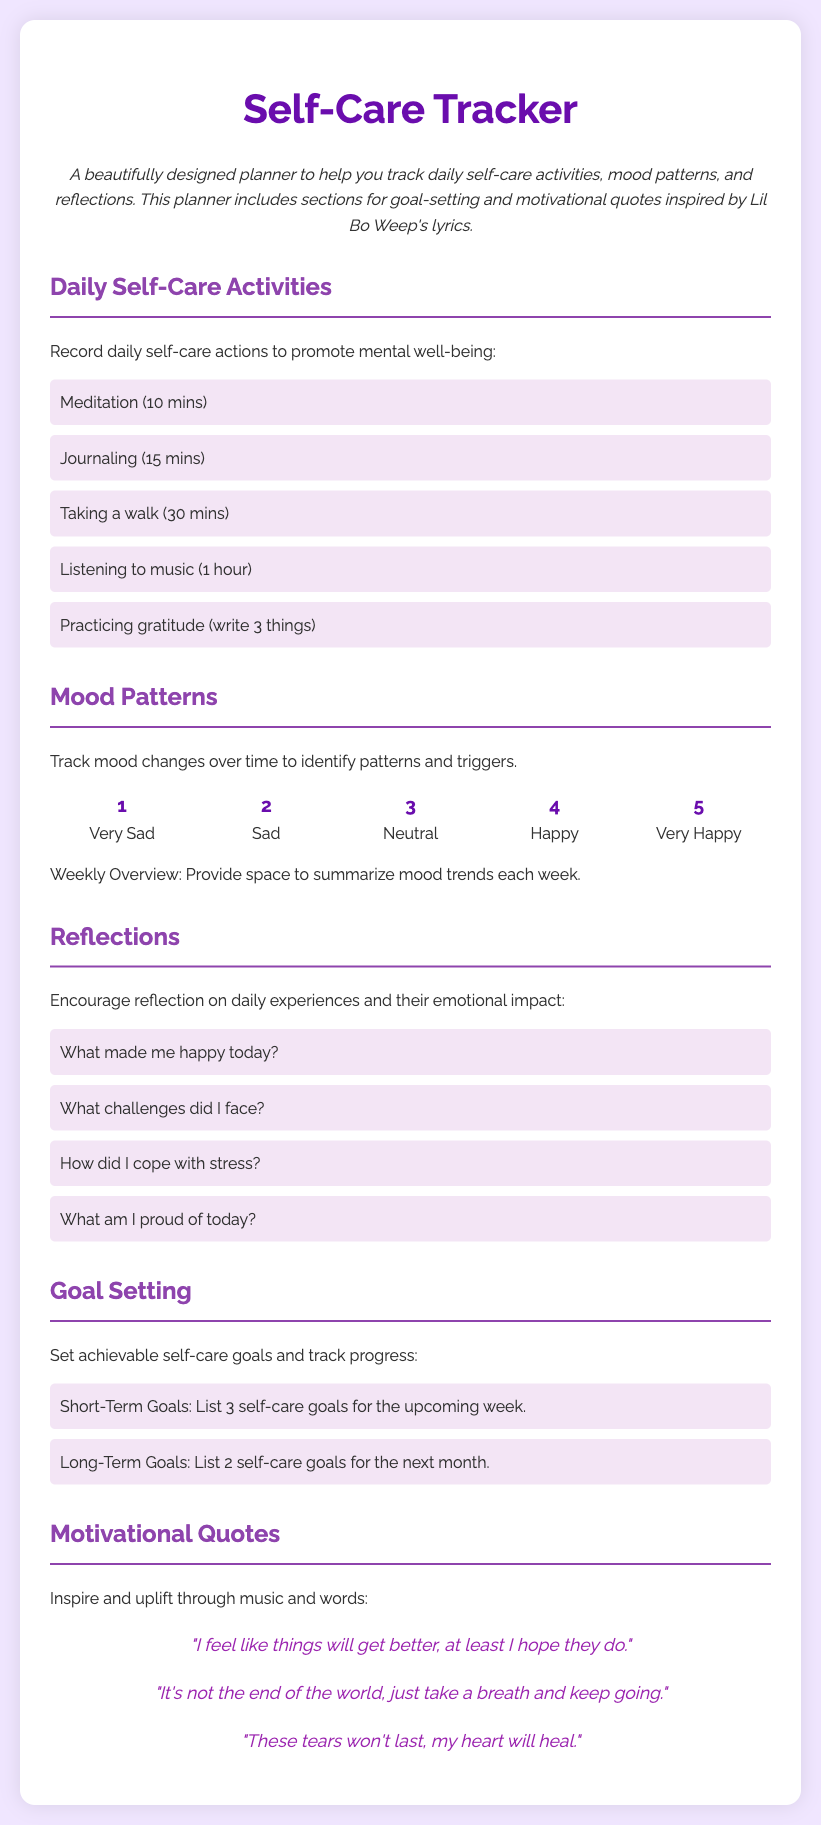What is the title of the document? The title of the document is found in the main heading at the top.
Answer: Self-Care Tracker How many daily self-care activities are listed? There are five activities listed under "Daily Self-Care Activities."
Answer: 5 What is one example of a mood rating? The document lists several mood ratings from 1 to 5.
Answer: Very Sad What section encourages users to reflect on their daily experiences? The section specifically focused on self-reflection is titled "Reflections."
Answer: Reflections What is the color of the background used in the document? The background color is specified in the style section of the document.
Answer: #f0e6ff Which motivational quote indicates hope for the future? One of the quotes specifically mentions feeling hopeful.
Answer: "I feel like things will get better, at least I hope they do." How many short-term goals does the document suggest writing? The document suggests listing three short-term self-care goals.
Answer: 3 What activity takes the longest time in the daily self-care list? The activity that takes the most time is specified in the daily self-care list.
Answer: Listening to music (1 hour) 